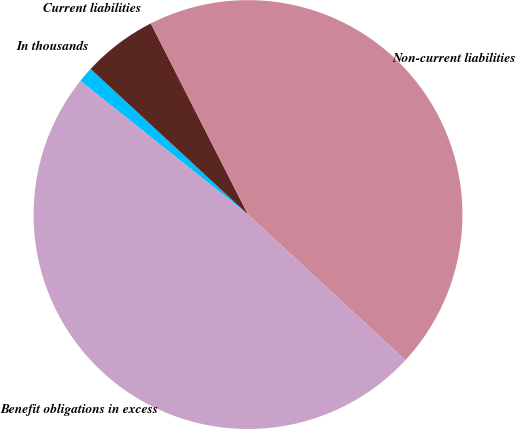Convert chart. <chart><loc_0><loc_0><loc_500><loc_500><pie_chart><fcel>In thousands<fcel>Current liabilities<fcel>Non-current liabilities<fcel>Benefit obligations in excess<nl><fcel>1.17%<fcel>5.63%<fcel>44.37%<fcel>48.83%<nl></chart> 